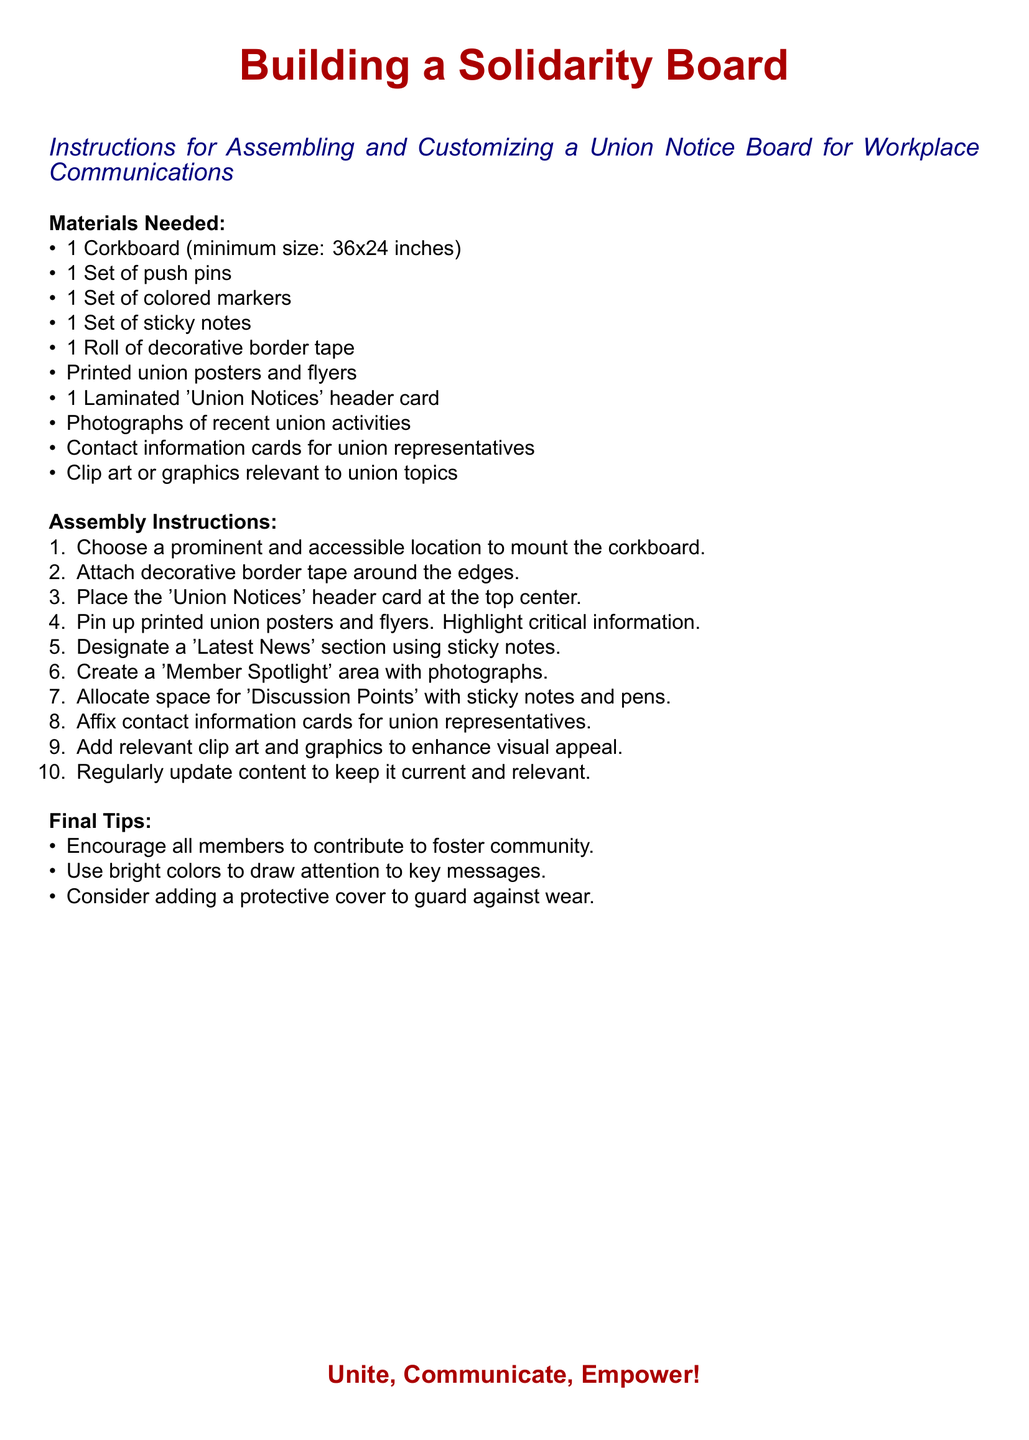what is the minimum size of the corkboard? The minimum size is specified in the materials needed section of the document.
Answer: 36x24 inches how many types of materials are listed? The materials needed section lists different items, so counting them gives the total.
Answer: 9 what color is the 'Union Notices' header card? The header card is part of the materials listed in the instructions, and while the color is not explicitly stated, it is implied to fit the theme.
Answer: Not specified which section is designated for the latest news? The assembly instructions indicate a specific area for current updates within the board structure.
Answer: Latest News what should be used to enhance visual appeal? The document suggests a particular item that adds to the overall aesthetics of the board.
Answer: Clip art or graphics what is the purpose of the 'Member Spotlight' area? This section is mentioned in the assembly instructions, highlighting its intended use for showcasing union members.
Answer: Photographs how often should the content be updated? The final tips section gives advice on maintaining the board's relevance, indicating a recommendation for frequency.
Answer: Regularly what is the main theme of the document? The title clearly conveys the central idea and purpose of creating a specific board for a union.
Answer: Solidarity Board 